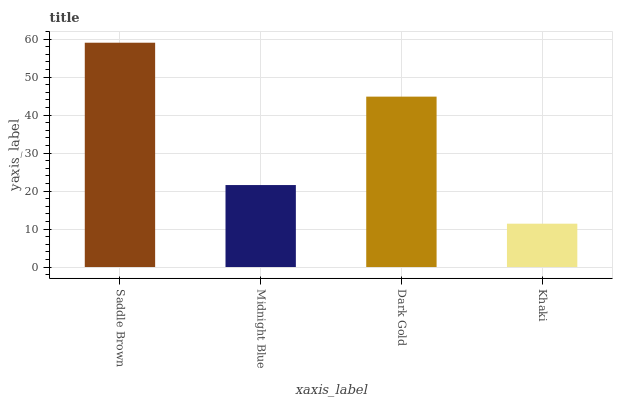Is Midnight Blue the minimum?
Answer yes or no. No. Is Midnight Blue the maximum?
Answer yes or no. No. Is Saddle Brown greater than Midnight Blue?
Answer yes or no. Yes. Is Midnight Blue less than Saddle Brown?
Answer yes or no. Yes. Is Midnight Blue greater than Saddle Brown?
Answer yes or no. No. Is Saddle Brown less than Midnight Blue?
Answer yes or no. No. Is Dark Gold the high median?
Answer yes or no. Yes. Is Midnight Blue the low median?
Answer yes or no. Yes. Is Midnight Blue the high median?
Answer yes or no. No. Is Khaki the low median?
Answer yes or no. No. 